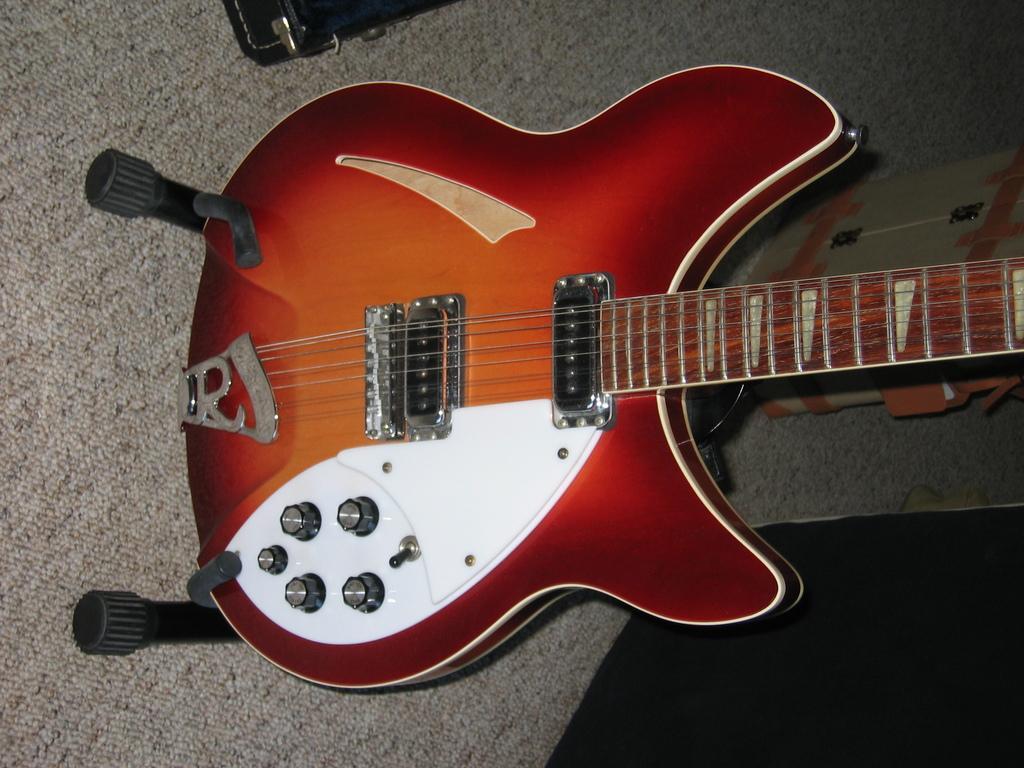Could you give a brief overview of what you see in this image? There is a guitar in the picture which is placed on the stands with strings and tuners here. The guitar is red in color. 